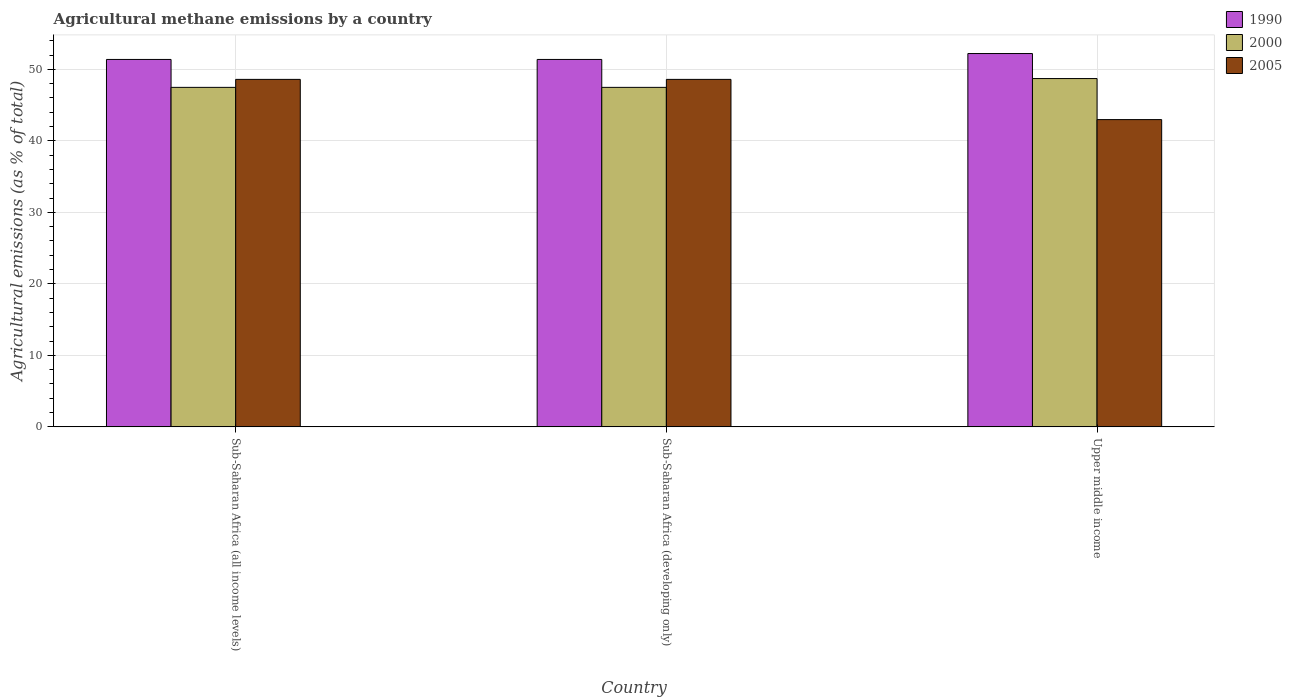Are the number of bars per tick equal to the number of legend labels?
Give a very brief answer. Yes. How many bars are there on the 2nd tick from the right?
Your answer should be compact. 3. What is the label of the 3rd group of bars from the left?
Keep it short and to the point. Upper middle income. In how many cases, is the number of bars for a given country not equal to the number of legend labels?
Give a very brief answer. 0. What is the amount of agricultural methane emitted in 2005 in Sub-Saharan Africa (all income levels)?
Your response must be concise. 48.6. Across all countries, what is the maximum amount of agricultural methane emitted in 2005?
Provide a short and direct response. 48.6. Across all countries, what is the minimum amount of agricultural methane emitted in 2005?
Ensure brevity in your answer.  42.98. In which country was the amount of agricultural methane emitted in 1990 maximum?
Give a very brief answer. Upper middle income. In which country was the amount of agricultural methane emitted in 2000 minimum?
Your response must be concise. Sub-Saharan Africa (all income levels). What is the total amount of agricultural methane emitted in 1990 in the graph?
Make the answer very short. 154.99. What is the difference between the amount of agricultural methane emitted in 1990 in Sub-Saharan Africa (all income levels) and the amount of agricultural methane emitted in 2005 in Sub-Saharan Africa (developing only)?
Your answer should be compact. 2.79. What is the average amount of agricultural methane emitted in 1990 per country?
Provide a short and direct response. 51.66. What is the difference between the amount of agricultural methane emitted of/in 2000 and amount of agricultural methane emitted of/in 1990 in Sub-Saharan Africa (all income levels)?
Your answer should be compact. -3.9. In how many countries, is the amount of agricultural methane emitted in 2000 greater than 10 %?
Your answer should be compact. 3. What is the ratio of the amount of agricultural methane emitted in 1990 in Sub-Saharan Africa (developing only) to that in Upper middle income?
Offer a terse response. 0.98. Is the amount of agricultural methane emitted in 2000 in Sub-Saharan Africa (all income levels) less than that in Sub-Saharan Africa (developing only)?
Your answer should be very brief. No. Is the difference between the amount of agricultural methane emitted in 2000 in Sub-Saharan Africa (all income levels) and Upper middle income greater than the difference between the amount of agricultural methane emitted in 1990 in Sub-Saharan Africa (all income levels) and Upper middle income?
Keep it short and to the point. No. What is the difference between the highest and the second highest amount of agricultural methane emitted in 1990?
Ensure brevity in your answer.  -0.83. What is the difference between the highest and the lowest amount of agricultural methane emitted in 2000?
Make the answer very short. 1.23. In how many countries, is the amount of agricultural methane emitted in 2000 greater than the average amount of agricultural methane emitted in 2000 taken over all countries?
Offer a terse response. 1. What does the 1st bar from the right in Upper middle income represents?
Provide a short and direct response. 2005. Are all the bars in the graph horizontal?
Make the answer very short. No. What is the difference between two consecutive major ticks on the Y-axis?
Your answer should be very brief. 10. Does the graph contain any zero values?
Make the answer very short. No. What is the title of the graph?
Provide a succinct answer. Agricultural methane emissions by a country. Does "1987" appear as one of the legend labels in the graph?
Offer a terse response. No. What is the label or title of the X-axis?
Make the answer very short. Country. What is the label or title of the Y-axis?
Provide a short and direct response. Agricultural emissions (as % of total). What is the Agricultural emissions (as % of total) in 1990 in Sub-Saharan Africa (all income levels)?
Keep it short and to the point. 51.39. What is the Agricultural emissions (as % of total) in 2000 in Sub-Saharan Africa (all income levels)?
Keep it short and to the point. 47.48. What is the Agricultural emissions (as % of total) in 2005 in Sub-Saharan Africa (all income levels)?
Your answer should be compact. 48.6. What is the Agricultural emissions (as % of total) in 1990 in Sub-Saharan Africa (developing only)?
Offer a terse response. 51.39. What is the Agricultural emissions (as % of total) of 2000 in Sub-Saharan Africa (developing only)?
Keep it short and to the point. 47.48. What is the Agricultural emissions (as % of total) of 2005 in Sub-Saharan Africa (developing only)?
Your answer should be very brief. 48.6. What is the Agricultural emissions (as % of total) in 1990 in Upper middle income?
Your answer should be very brief. 52.21. What is the Agricultural emissions (as % of total) in 2000 in Upper middle income?
Ensure brevity in your answer.  48.72. What is the Agricultural emissions (as % of total) of 2005 in Upper middle income?
Your answer should be compact. 42.98. Across all countries, what is the maximum Agricultural emissions (as % of total) in 1990?
Offer a very short reply. 52.21. Across all countries, what is the maximum Agricultural emissions (as % of total) in 2000?
Give a very brief answer. 48.72. Across all countries, what is the maximum Agricultural emissions (as % of total) in 2005?
Your answer should be very brief. 48.6. Across all countries, what is the minimum Agricultural emissions (as % of total) in 1990?
Make the answer very short. 51.39. Across all countries, what is the minimum Agricultural emissions (as % of total) of 2000?
Your answer should be very brief. 47.48. Across all countries, what is the minimum Agricultural emissions (as % of total) in 2005?
Make the answer very short. 42.98. What is the total Agricultural emissions (as % of total) in 1990 in the graph?
Keep it short and to the point. 154.99. What is the total Agricultural emissions (as % of total) of 2000 in the graph?
Offer a terse response. 143.68. What is the total Agricultural emissions (as % of total) in 2005 in the graph?
Offer a terse response. 140.17. What is the difference between the Agricultural emissions (as % of total) in 2005 in Sub-Saharan Africa (all income levels) and that in Sub-Saharan Africa (developing only)?
Ensure brevity in your answer.  0. What is the difference between the Agricultural emissions (as % of total) in 1990 in Sub-Saharan Africa (all income levels) and that in Upper middle income?
Provide a short and direct response. -0.83. What is the difference between the Agricultural emissions (as % of total) in 2000 in Sub-Saharan Africa (all income levels) and that in Upper middle income?
Give a very brief answer. -1.23. What is the difference between the Agricultural emissions (as % of total) of 2005 in Sub-Saharan Africa (all income levels) and that in Upper middle income?
Provide a short and direct response. 5.62. What is the difference between the Agricultural emissions (as % of total) in 1990 in Sub-Saharan Africa (developing only) and that in Upper middle income?
Your answer should be compact. -0.83. What is the difference between the Agricultural emissions (as % of total) in 2000 in Sub-Saharan Africa (developing only) and that in Upper middle income?
Provide a succinct answer. -1.23. What is the difference between the Agricultural emissions (as % of total) in 2005 in Sub-Saharan Africa (developing only) and that in Upper middle income?
Provide a short and direct response. 5.62. What is the difference between the Agricultural emissions (as % of total) of 1990 in Sub-Saharan Africa (all income levels) and the Agricultural emissions (as % of total) of 2000 in Sub-Saharan Africa (developing only)?
Your answer should be compact. 3.9. What is the difference between the Agricultural emissions (as % of total) in 1990 in Sub-Saharan Africa (all income levels) and the Agricultural emissions (as % of total) in 2005 in Sub-Saharan Africa (developing only)?
Provide a succinct answer. 2.79. What is the difference between the Agricultural emissions (as % of total) in 2000 in Sub-Saharan Africa (all income levels) and the Agricultural emissions (as % of total) in 2005 in Sub-Saharan Africa (developing only)?
Your answer should be very brief. -1.12. What is the difference between the Agricultural emissions (as % of total) in 1990 in Sub-Saharan Africa (all income levels) and the Agricultural emissions (as % of total) in 2000 in Upper middle income?
Your answer should be very brief. 2.67. What is the difference between the Agricultural emissions (as % of total) of 1990 in Sub-Saharan Africa (all income levels) and the Agricultural emissions (as % of total) of 2005 in Upper middle income?
Keep it short and to the point. 8.41. What is the difference between the Agricultural emissions (as % of total) in 2000 in Sub-Saharan Africa (all income levels) and the Agricultural emissions (as % of total) in 2005 in Upper middle income?
Provide a succinct answer. 4.51. What is the difference between the Agricultural emissions (as % of total) of 1990 in Sub-Saharan Africa (developing only) and the Agricultural emissions (as % of total) of 2000 in Upper middle income?
Your response must be concise. 2.67. What is the difference between the Agricultural emissions (as % of total) of 1990 in Sub-Saharan Africa (developing only) and the Agricultural emissions (as % of total) of 2005 in Upper middle income?
Provide a succinct answer. 8.41. What is the difference between the Agricultural emissions (as % of total) in 2000 in Sub-Saharan Africa (developing only) and the Agricultural emissions (as % of total) in 2005 in Upper middle income?
Give a very brief answer. 4.51. What is the average Agricultural emissions (as % of total) of 1990 per country?
Keep it short and to the point. 51.66. What is the average Agricultural emissions (as % of total) in 2000 per country?
Keep it short and to the point. 47.89. What is the average Agricultural emissions (as % of total) of 2005 per country?
Make the answer very short. 46.72. What is the difference between the Agricultural emissions (as % of total) of 1990 and Agricultural emissions (as % of total) of 2000 in Sub-Saharan Africa (all income levels)?
Make the answer very short. 3.9. What is the difference between the Agricultural emissions (as % of total) of 1990 and Agricultural emissions (as % of total) of 2005 in Sub-Saharan Africa (all income levels)?
Give a very brief answer. 2.79. What is the difference between the Agricultural emissions (as % of total) of 2000 and Agricultural emissions (as % of total) of 2005 in Sub-Saharan Africa (all income levels)?
Your answer should be very brief. -1.12. What is the difference between the Agricultural emissions (as % of total) in 1990 and Agricultural emissions (as % of total) in 2000 in Sub-Saharan Africa (developing only)?
Ensure brevity in your answer.  3.9. What is the difference between the Agricultural emissions (as % of total) of 1990 and Agricultural emissions (as % of total) of 2005 in Sub-Saharan Africa (developing only)?
Offer a terse response. 2.79. What is the difference between the Agricultural emissions (as % of total) of 2000 and Agricultural emissions (as % of total) of 2005 in Sub-Saharan Africa (developing only)?
Your answer should be compact. -1.12. What is the difference between the Agricultural emissions (as % of total) of 1990 and Agricultural emissions (as % of total) of 2000 in Upper middle income?
Give a very brief answer. 3.5. What is the difference between the Agricultural emissions (as % of total) of 1990 and Agricultural emissions (as % of total) of 2005 in Upper middle income?
Provide a succinct answer. 9.24. What is the difference between the Agricultural emissions (as % of total) of 2000 and Agricultural emissions (as % of total) of 2005 in Upper middle income?
Keep it short and to the point. 5.74. What is the ratio of the Agricultural emissions (as % of total) in 2000 in Sub-Saharan Africa (all income levels) to that in Sub-Saharan Africa (developing only)?
Provide a short and direct response. 1. What is the ratio of the Agricultural emissions (as % of total) of 2005 in Sub-Saharan Africa (all income levels) to that in Sub-Saharan Africa (developing only)?
Your response must be concise. 1. What is the ratio of the Agricultural emissions (as % of total) in 1990 in Sub-Saharan Africa (all income levels) to that in Upper middle income?
Your response must be concise. 0.98. What is the ratio of the Agricultural emissions (as % of total) in 2000 in Sub-Saharan Africa (all income levels) to that in Upper middle income?
Provide a succinct answer. 0.97. What is the ratio of the Agricultural emissions (as % of total) in 2005 in Sub-Saharan Africa (all income levels) to that in Upper middle income?
Offer a very short reply. 1.13. What is the ratio of the Agricultural emissions (as % of total) of 1990 in Sub-Saharan Africa (developing only) to that in Upper middle income?
Keep it short and to the point. 0.98. What is the ratio of the Agricultural emissions (as % of total) in 2000 in Sub-Saharan Africa (developing only) to that in Upper middle income?
Offer a terse response. 0.97. What is the ratio of the Agricultural emissions (as % of total) of 2005 in Sub-Saharan Africa (developing only) to that in Upper middle income?
Keep it short and to the point. 1.13. What is the difference between the highest and the second highest Agricultural emissions (as % of total) of 1990?
Make the answer very short. 0.83. What is the difference between the highest and the second highest Agricultural emissions (as % of total) of 2000?
Keep it short and to the point. 1.23. What is the difference between the highest and the second highest Agricultural emissions (as % of total) in 2005?
Keep it short and to the point. 0. What is the difference between the highest and the lowest Agricultural emissions (as % of total) in 1990?
Keep it short and to the point. 0.83. What is the difference between the highest and the lowest Agricultural emissions (as % of total) in 2000?
Keep it short and to the point. 1.23. What is the difference between the highest and the lowest Agricultural emissions (as % of total) of 2005?
Provide a short and direct response. 5.62. 